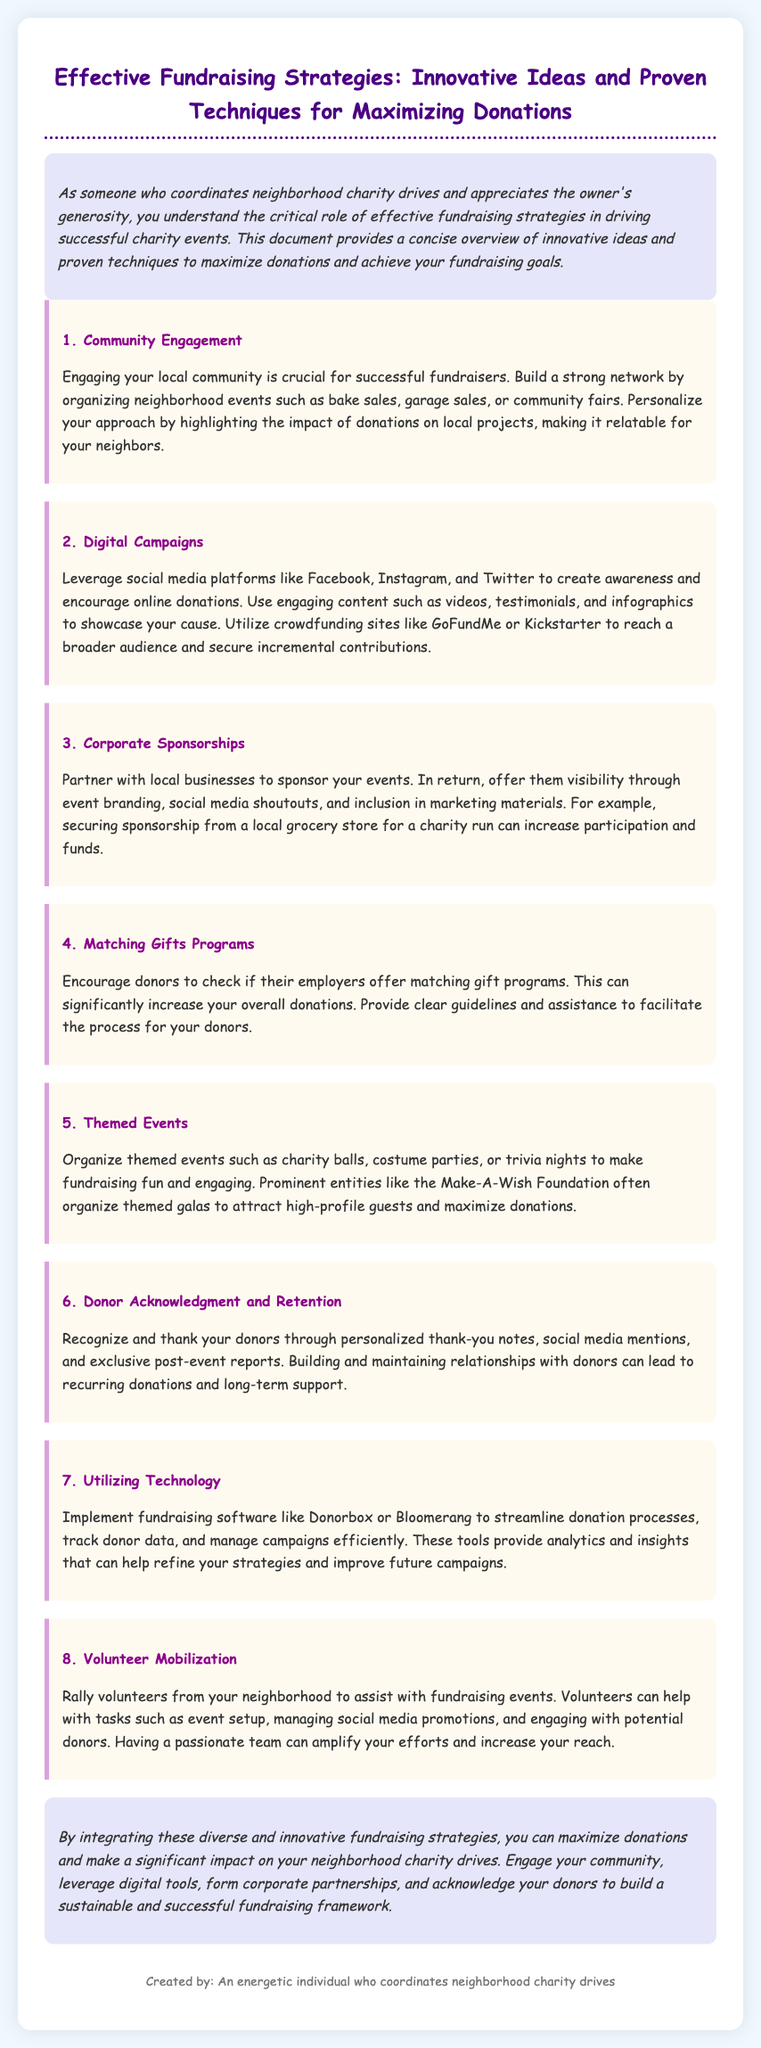What is the section title about community fundraising? The title is directly mentioned in the document as "Community Engagement".
Answer: Community Engagement Which digital platforms are mentioned for fundraising campaigns? The document lists specific platforms like Facebook, Instagram, and Twitter.
Answer: Facebook, Instagram, Twitter What is a key benefit of corporate sponsorships according to the document? The document highlights that sponsorships provide businesses visibility through event branding.
Answer: Visibility How can matching gifts programs impact donations? The document states that they can significantly increase overall donations.
Answer: Significantly increase What type of events are suggested to make fundraising fun? The document refers to themed events such as charity balls and costume parties.
Answer: Themed events What tool is recommended for managing fundraising processes effectively? The document mentions utilizing fundraising software like Donorbox or Bloomerang.
Answer: Donorbox, Bloomerang What is emphasized as critical for retaining donors? The document specifies recognizing and thanking donors as essential for retention.
Answer: Recognizing and thanking How can volunteers contribute to fundraising events? The document outlines that volunteers can assist with various tasks including event setup.
Answer: Assist with tasks What is the primary purpose of the document? The document aims to provide strategies for maximizing donations in fundraising efforts.
Answer: Maximizing donations 